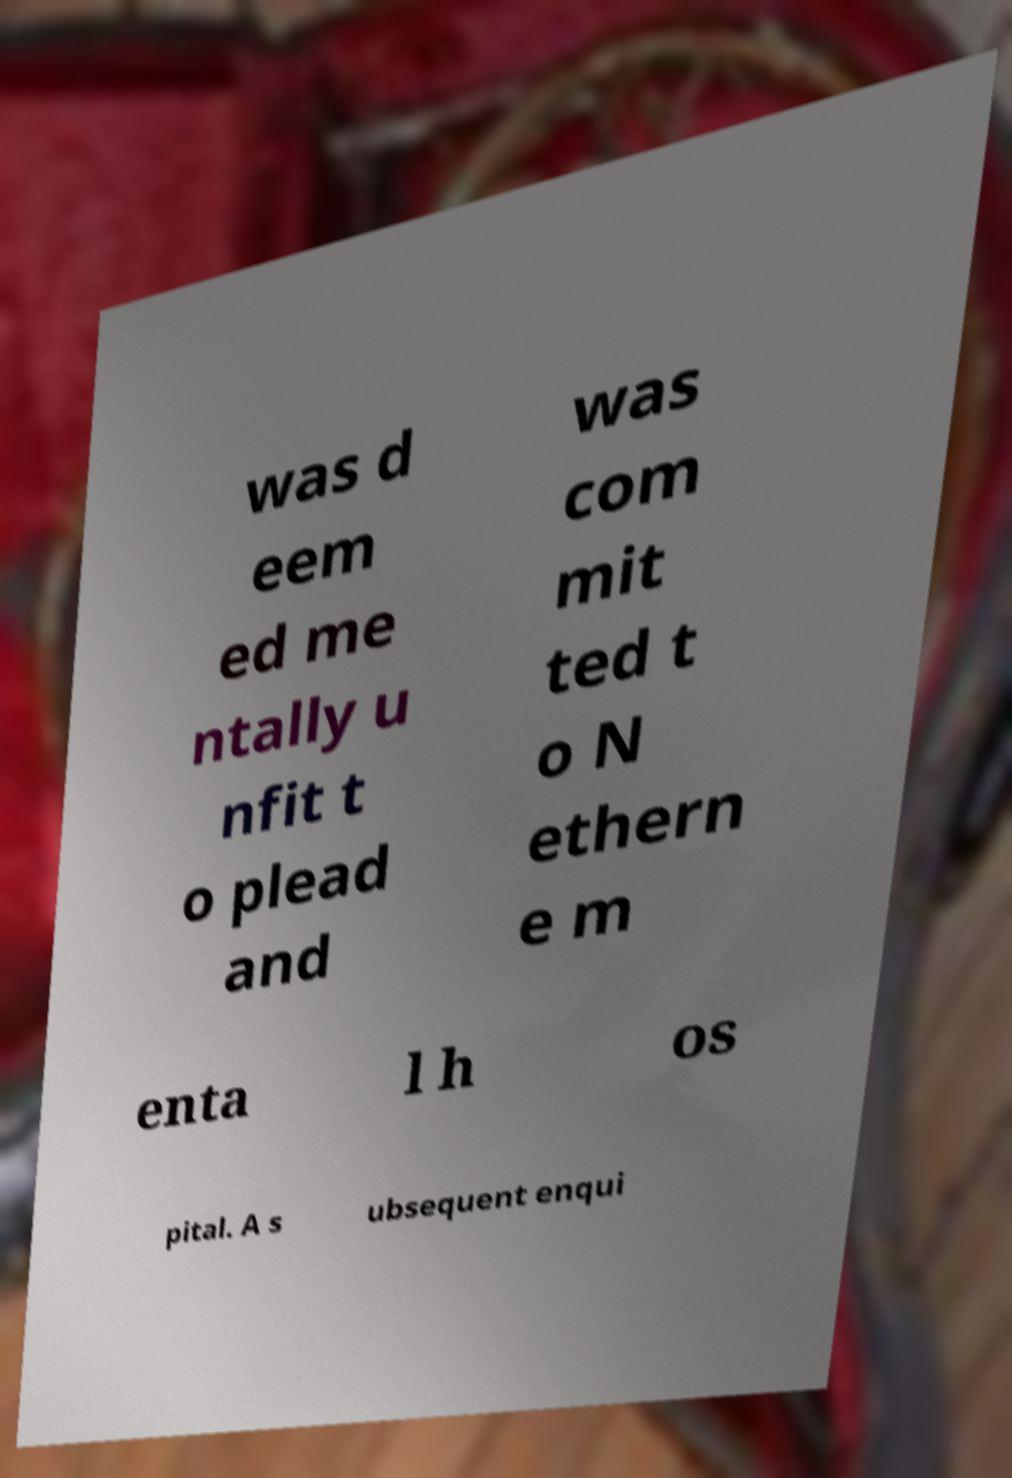What messages or text are displayed in this image? I need them in a readable, typed format. was d eem ed me ntally u nfit t o plead and was com mit ted t o N ethern e m enta l h os pital. A s ubsequent enqui 